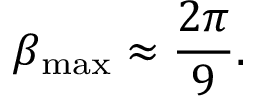Convert formula to latex. <formula><loc_0><loc_0><loc_500><loc_500>\beta _ { \max } \approx \frac { 2 \pi } { 9 } .</formula> 